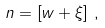Convert formula to latex. <formula><loc_0><loc_0><loc_500><loc_500>n = \left [ w + \xi \right ] \, ,</formula> 